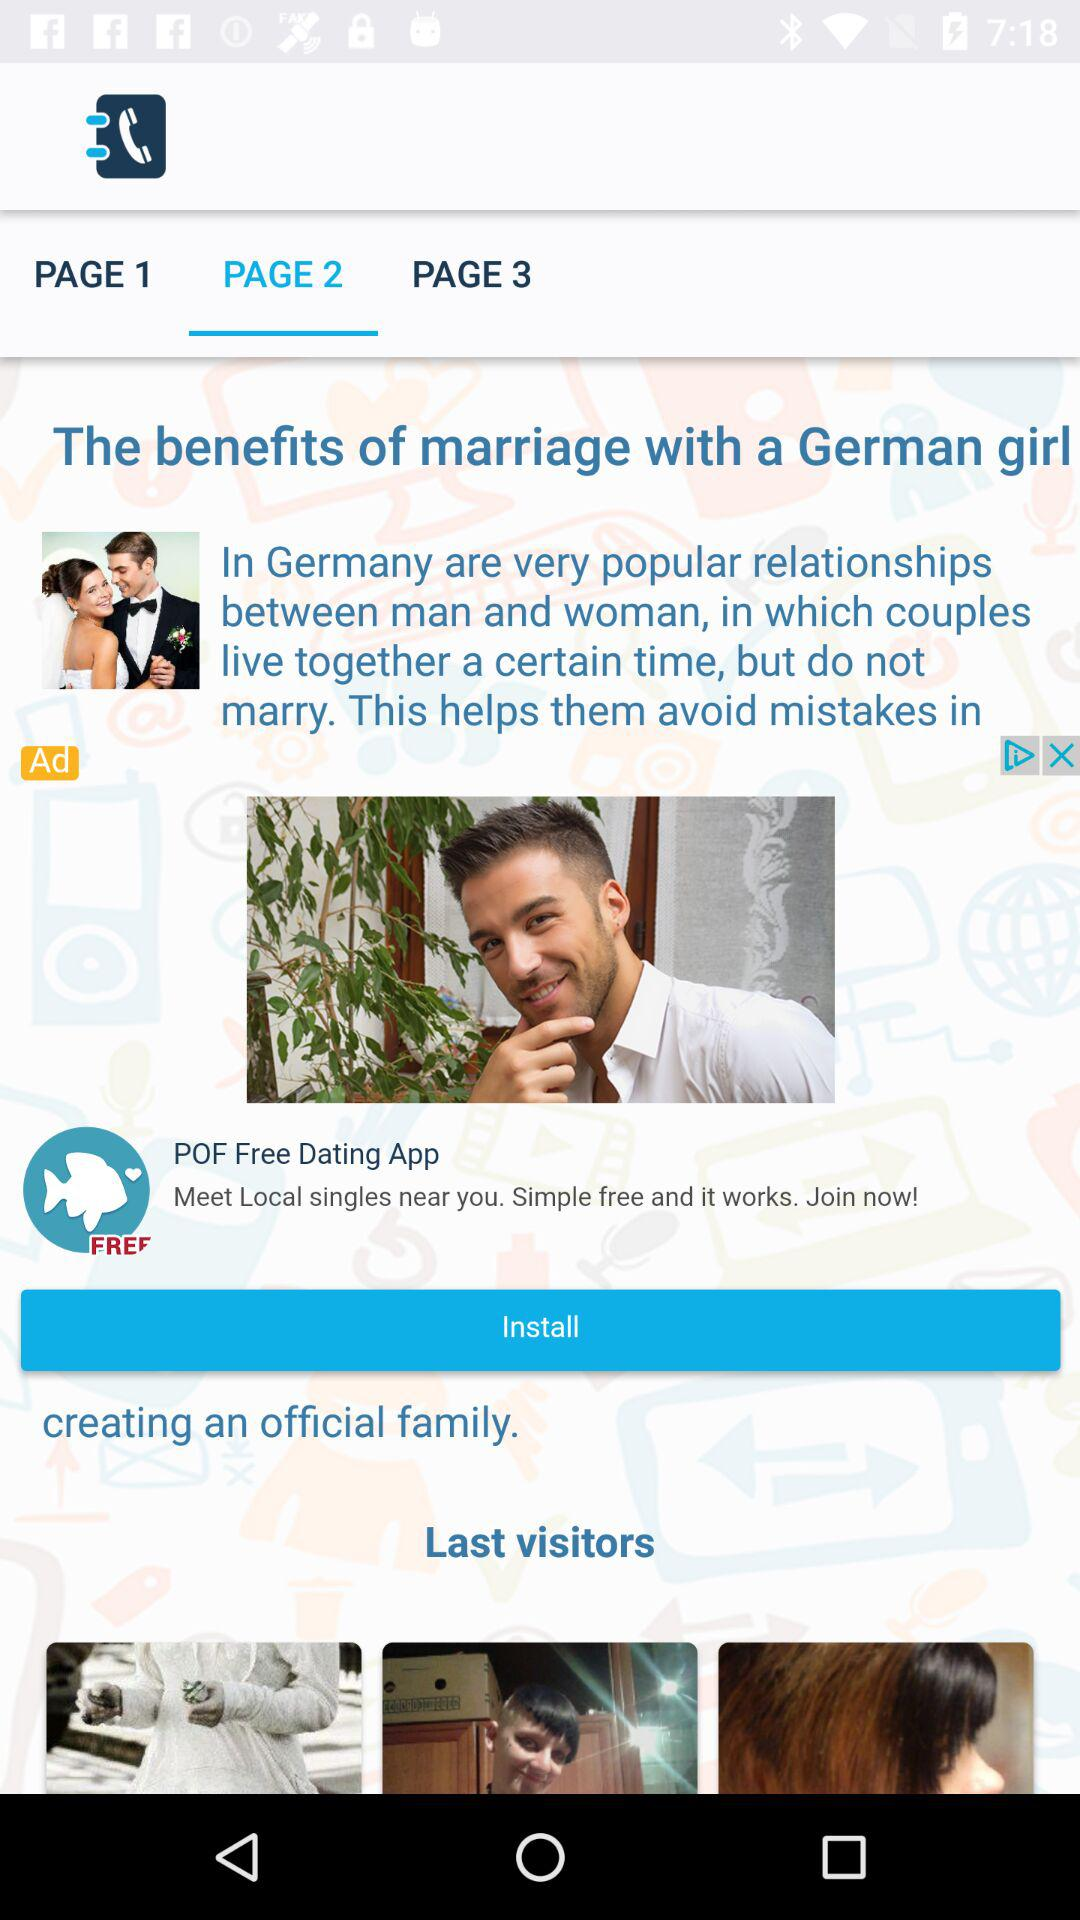Which tab is selected? The selected tab is "PAGE 2". 